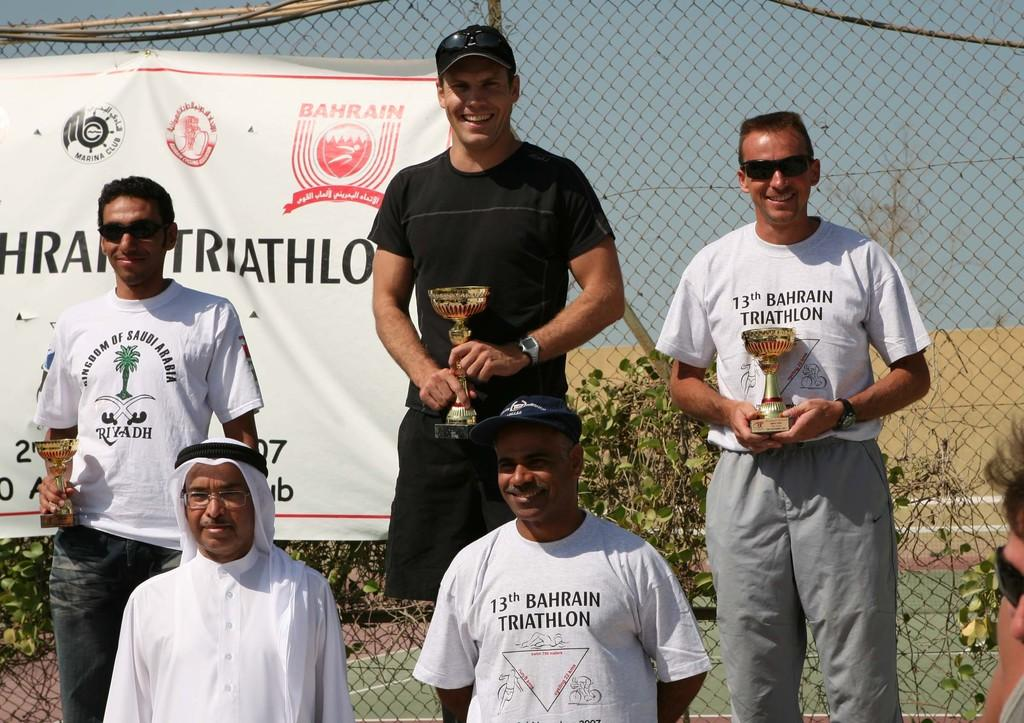Provide a one-sentence caption for the provided image. Group of men taking a picture holding trophies including one with a shirt that says "13th Bahrain Triathlon". 